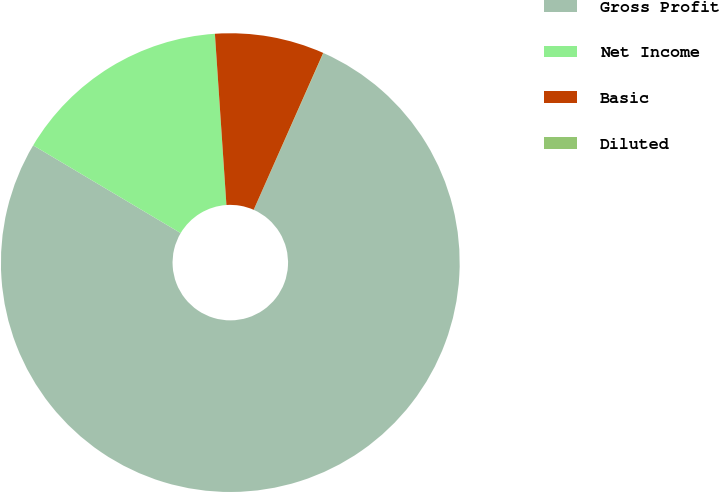Convert chart. <chart><loc_0><loc_0><loc_500><loc_500><pie_chart><fcel>Gross Profit<fcel>Net Income<fcel>Basic<fcel>Diluted<nl><fcel>76.88%<fcel>15.39%<fcel>7.71%<fcel>0.02%<nl></chart> 